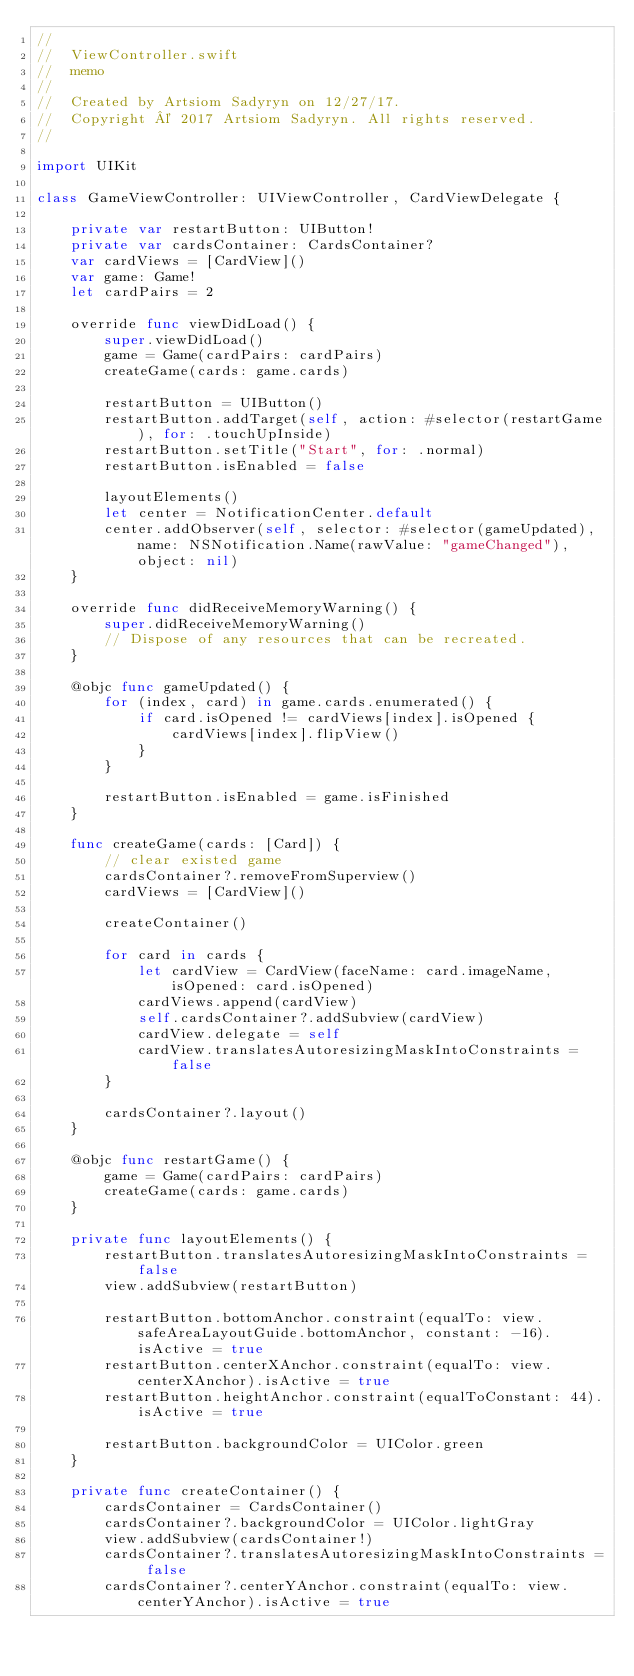<code> <loc_0><loc_0><loc_500><loc_500><_Swift_>//
//  ViewController.swift
//  memo
//
//  Created by Artsiom Sadyryn on 12/27/17.
//  Copyright © 2017 Artsiom Sadyryn. All rights reserved.
//

import UIKit

class GameViewController: UIViewController, CardViewDelegate {
    
    private var restartButton: UIButton!
    private var cardsContainer: CardsContainer?
    var cardViews = [CardView]()
    var game: Game!
    let cardPairs = 2
    
    override func viewDidLoad() {
        super.viewDidLoad()
        game = Game(cardPairs: cardPairs)
        createGame(cards: game.cards)
        
        restartButton = UIButton()
        restartButton.addTarget(self, action: #selector(restartGame), for: .touchUpInside)
        restartButton.setTitle("Start", for: .normal)
        restartButton.isEnabled = false
        
        layoutElements()
        let center = NotificationCenter.default
        center.addObserver(self, selector: #selector(gameUpdated), name: NSNotification.Name(rawValue: "gameChanged"), object: nil)
    }
    
    override func didReceiveMemoryWarning() {
        super.didReceiveMemoryWarning()
        // Dispose of any resources that can be recreated.
    }
    
    @objc func gameUpdated() {
        for (index, card) in game.cards.enumerated() {
            if card.isOpened != cardViews[index].isOpened {
                cardViews[index].flipView()
            }
        }
        
        restartButton.isEnabled = game.isFinished
    }
    
    func createGame(cards: [Card]) {
        // clear existed game
        cardsContainer?.removeFromSuperview()
        cardViews = [CardView]()
        
        createContainer()
        
        for card in cards {
            let cardView = CardView(faceName: card.imageName, isOpened: card.isOpened)
            cardViews.append(cardView)
            self.cardsContainer?.addSubview(cardView)
            cardView.delegate = self
            cardView.translatesAutoresizingMaskIntoConstraints = false
        }
        
        cardsContainer?.layout()
    }
    
    @objc func restartGame() {
        game = Game(cardPairs: cardPairs)
        createGame(cards: game.cards)
    }
    
    private func layoutElements() {
        restartButton.translatesAutoresizingMaskIntoConstraints = false
        view.addSubview(restartButton)
        
        restartButton.bottomAnchor.constraint(equalTo: view.safeAreaLayoutGuide.bottomAnchor, constant: -16).isActive = true
        restartButton.centerXAnchor.constraint(equalTo: view.centerXAnchor).isActive = true
        restartButton.heightAnchor.constraint(equalToConstant: 44).isActive = true
        
        restartButton.backgroundColor = UIColor.green
    }
    
    private func createContainer() {
        cardsContainer = CardsContainer()
        cardsContainer?.backgroundColor = UIColor.lightGray
        view.addSubview(cardsContainer!)
        cardsContainer?.translatesAutoresizingMaskIntoConstraints = false
        cardsContainer?.centerYAnchor.constraint(equalTo: view.centerYAnchor).isActive = true</code> 